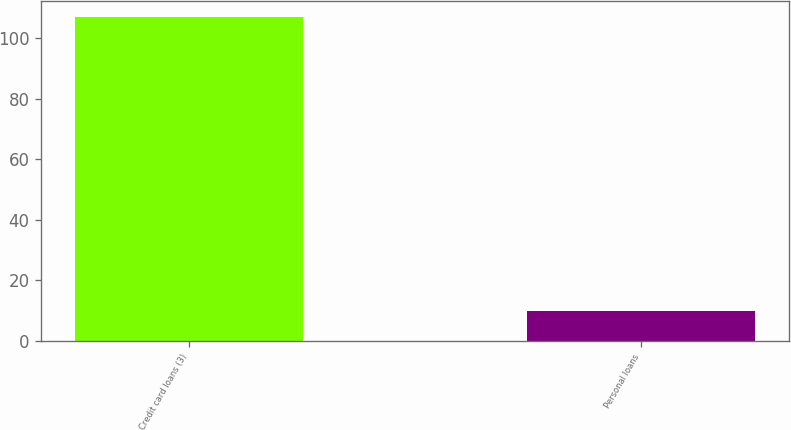Convert chart. <chart><loc_0><loc_0><loc_500><loc_500><bar_chart><fcel>Credit card loans (3)<fcel>Personal loans<nl><fcel>107<fcel>10<nl></chart> 